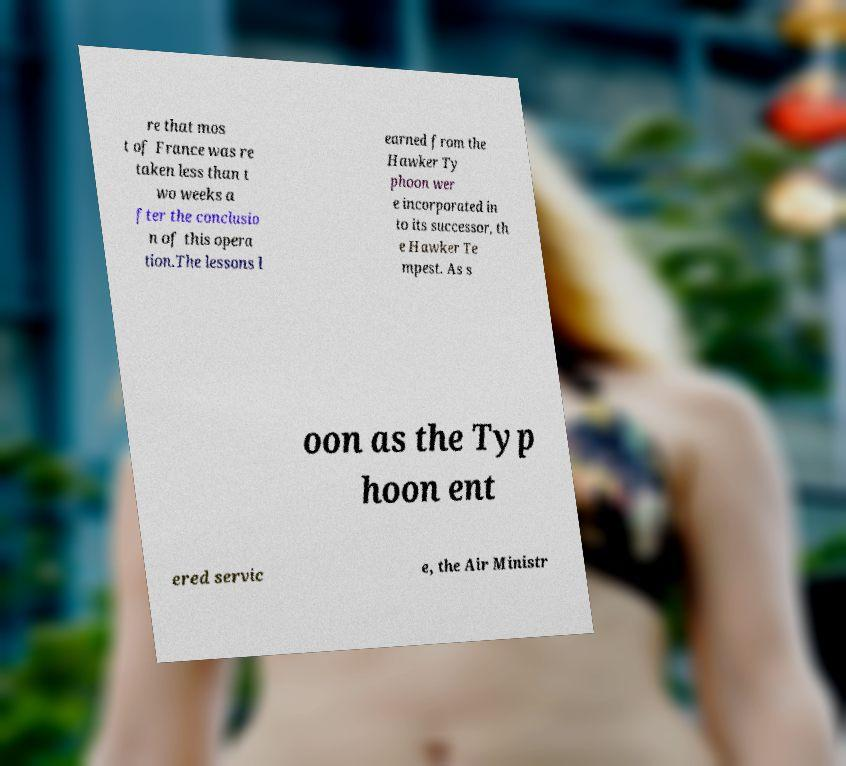I need the written content from this picture converted into text. Can you do that? re that mos t of France was re taken less than t wo weeks a fter the conclusio n of this opera tion.The lessons l earned from the Hawker Ty phoon wer e incorporated in to its successor, th e Hawker Te mpest. As s oon as the Typ hoon ent ered servic e, the Air Ministr 